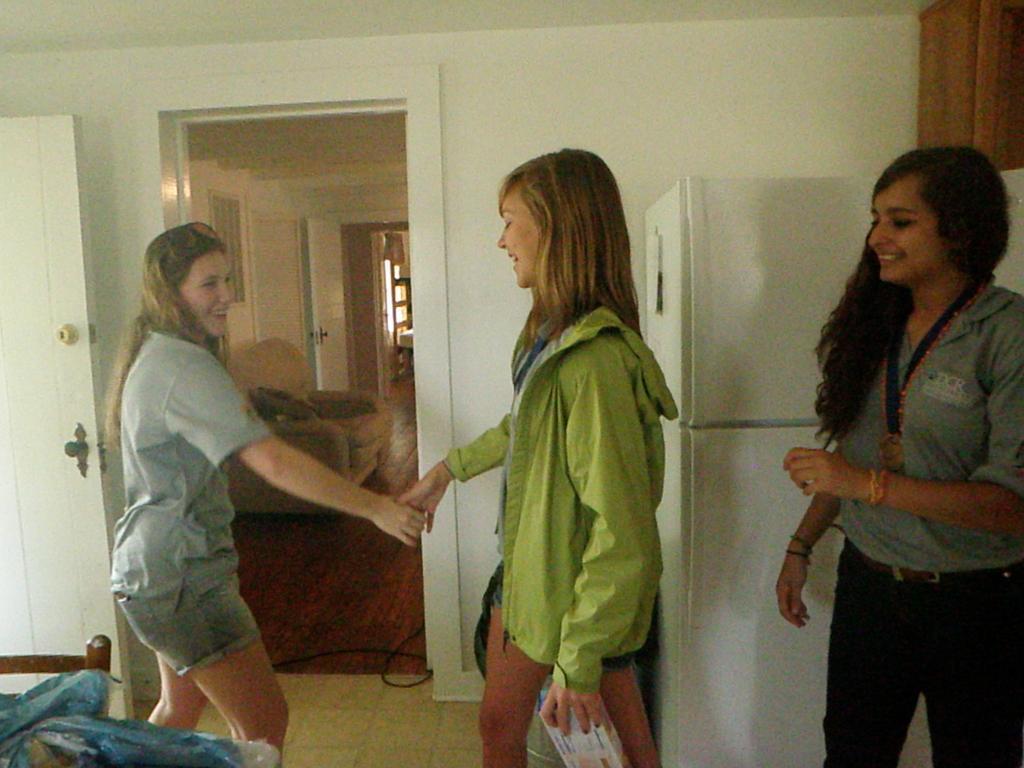Please provide a concise description of this image. In this picture we can see three girls, on the right side there is a refrigerator, we can see a sofa in the background, there is a wall here, on the left side there is a door, this girl is holding something. 